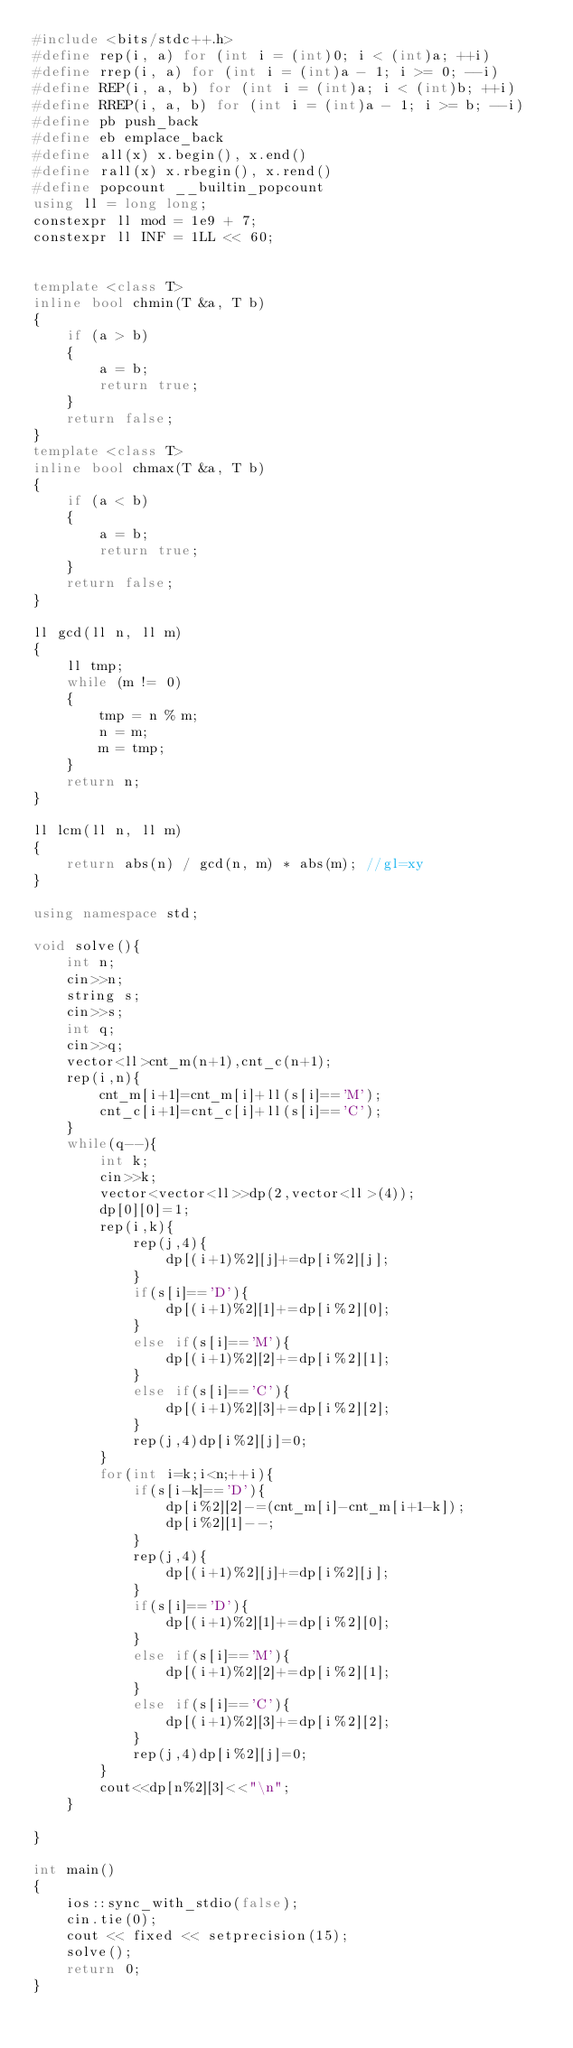Convert code to text. <code><loc_0><loc_0><loc_500><loc_500><_C++_>#include <bits/stdc++.h>
#define rep(i, a) for (int i = (int)0; i < (int)a; ++i)
#define rrep(i, a) for (int i = (int)a - 1; i >= 0; --i)
#define REP(i, a, b) for (int i = (int)a; i < (int)b; ++i)
#define RREP(i, a, b) for (int i = (int)a - 1; i >= b; --i)
#define pb push_back
#define eb emplace_back
#define all(x) x.begin(), x.end()
#define rall(x) x.rbegin(), x.rend()
#define popcount __builtin_popcount
using ll = long long;
constexpr ll mod = 1e9 + 7;
constexpr ll INF = 1LL << 60;


template <class T>
inline bool chmin(T &a, T b)
{
	if (a > b)
	{
		a = b;
		return true;
	}
	return false;
}
template <class T>
inline bool chmax(T &a, T b)
{
	if (a < b)
	{
		a = b;
		return true;
	}
	return false;
}

ll gcd(ll n, ll m)
{
	ll tmp;
	while (m != 0)
	{
		tmp = n % m;
		n = m;
		m = tmp;
	}
	return n;
}

ll lcm(ll n, ll m)
{
	return abs(n) / gcd(n, m) * abs(m); //gl=xy
}

using namespace std;

void solve(){
	int n;
	cin>>n;
	string s;
	cin>>s;
	int q;
	cin>>q;
	vector<ll>cnt_m(n+1),cnt_c(n+1);
	rep(i,n){
		cnt_m[i+1]=cnt_m[i]+ll(s[i]=='M');
		cnt_c[i+1]=cnt_c[i]+ll(s[i]=='C');
	}
	while(q--){
		int k;
		cin>>k;
		vector<vector<ll>>dp(2,vector<ll>(4));
		dp[0][0]=1;
		rep(i,k){
			rep(j,4){
				dp[(i+1)%2][j]+=dp[i%2][j];
			}
			if(s[i]=='D'){
				dp[(i+1)%2][1]+=dp[i%2][0];
			}
			else if(s[i]=='M'){
				dp[(i+1)%2][2]+=dp[i%2][1];
			}
			else if(s[i]=='C'){
				dp[(i+1)%2][3]+=dp[i%2][2];
			}
			rep(j,4)dp[i%2][j]=0;
		}
		for(int i=k;i<n;++i){
			if(s[i-k]=='D'){
				dp[i%2][2]-=(cnt_m[i]-cnt_m[i+1-k]);
				dp[i%2][1]--;
			}
			rep(j,4){
				dp[(i+1)%2][j]+=dp[i%2][j];
			}
			if(s[i]=='D'){
				dp[(i+1)%2][1]+=dp[i%2][0];
			}
			else if(s[i]=='M'){
				dp[(i+1)%2][2]+=dp[i%2][1];
			}
			else if(s[i]=='C'){
				dp[(i+1)%2][3]+=dp[i%2][2];
			}
			rep(j,4)dp[i%2][j]=0;
		}
		cout<<dp[n%2][3]<<"\n";
	}
	
}

int main()
{
	ios::sync_with_stdio(false);
	cin.tie(0);
	cout << fixed << setprecision(15);
	solve();
	return 0;
}
</code> 